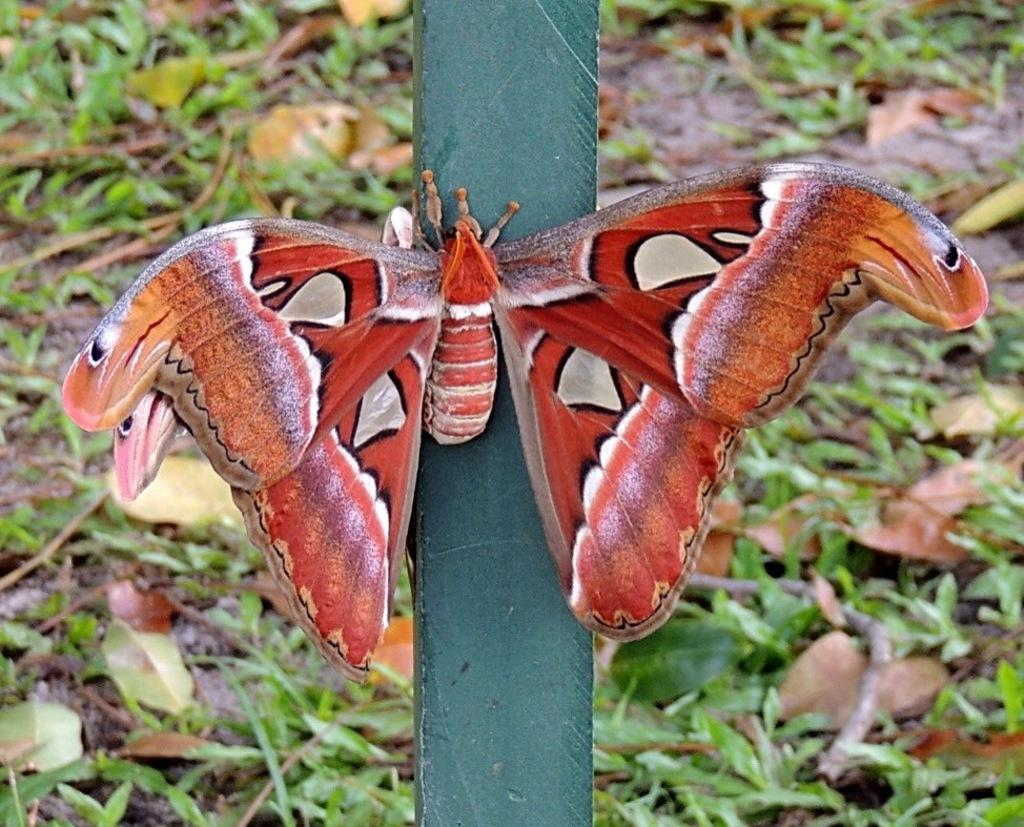What is the main subject of the image? There is a butterfly on a stick in the image. What can be seen on the ground in the image? There are leaves and sticks on the ground in the image. What type of invention is being demonstrated on the sidewalk in the image? There is no sidewalk or invention present in the image; it features a butterfly on a stick and leaves and sticks on the ground. Can you tell me how many bees are buzzing around the butterfly in the image? There are no bees present in the image; it only features a butterfly on a stick. 